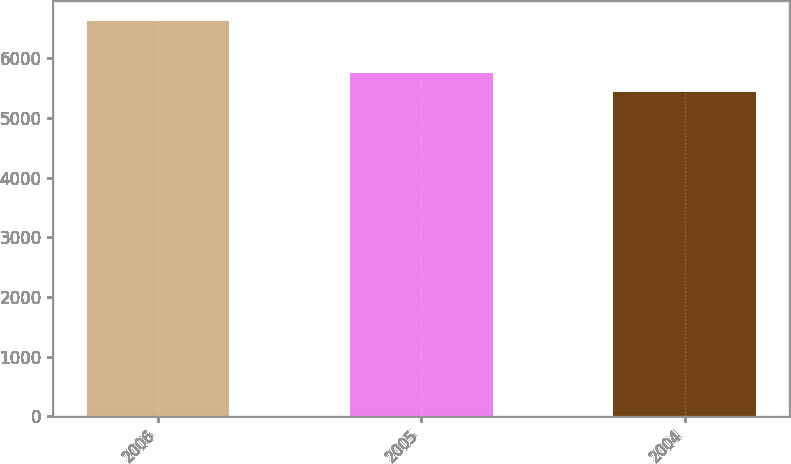Convert chart to OTSL. <chart><loc_0><loc_0><loc_500><loc_500><bar_chart><fcel>2006<fcel>2005<fcel>2004<nl><fcel>6621.5<fcel>5751.2<fcel>5440.2<nl></chart> 